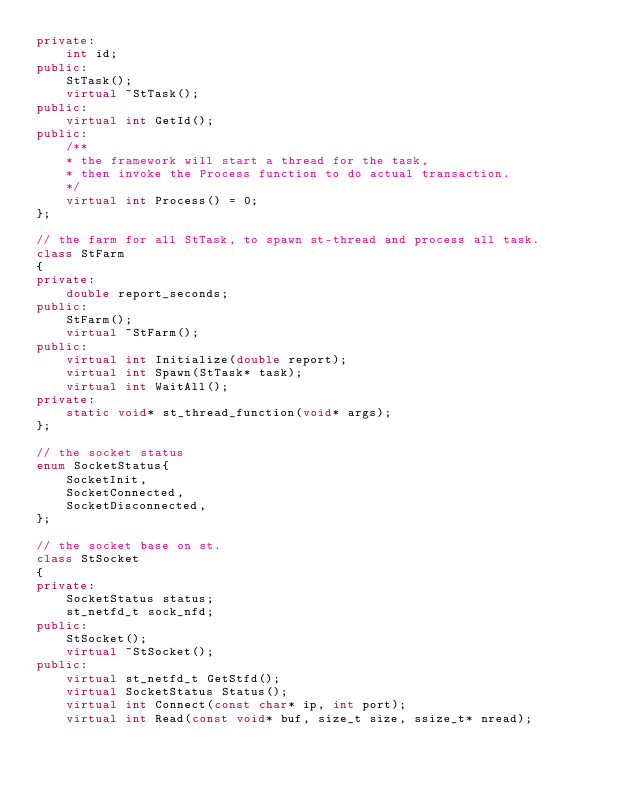Convert code to text. <code><loc_0><loc_0><loc_500><loc_500><_C++_>private:
    int id;
public:
    StTask();
    virtual ~StTask();
public:
    virtual int GetId();
public:
    /**
    * the framework will start a thread for the task, 
    * then invoke the Process function to do actual transaction.
    */
    virtual int Process() = 0;
};

// the farm for all StTask, to spawn st-thread and process all task.
class StFarm
{
private:
    double report_seconds;
public:
    StFarm();
    virtual ~StFarm();
public:
    virtual int Initialize(double report);
    virtual int Spawn(StTask* task);
    virtual int WaitAll();
private:
    static void* st_thread_function(void* args);
};

// the socket status
enum SocketStatus{
    SocketInit,
    SocketConnected,
    SocketDisconnected,
};

// the socket base on st.
class StSocket
{
private:
    SocketStatus status;
    st_netfd_t sock_nfd;
public:
    StSocket();
    virtual ~StSocket();
public:
    virtual st_netfd_t GetStfd();
    virtual SocketStatus Status();
    virtual int Connect(const char* ip, int port);
    virtual int Read(const void* buf, size_t size, ssize_t* nread);</code> 